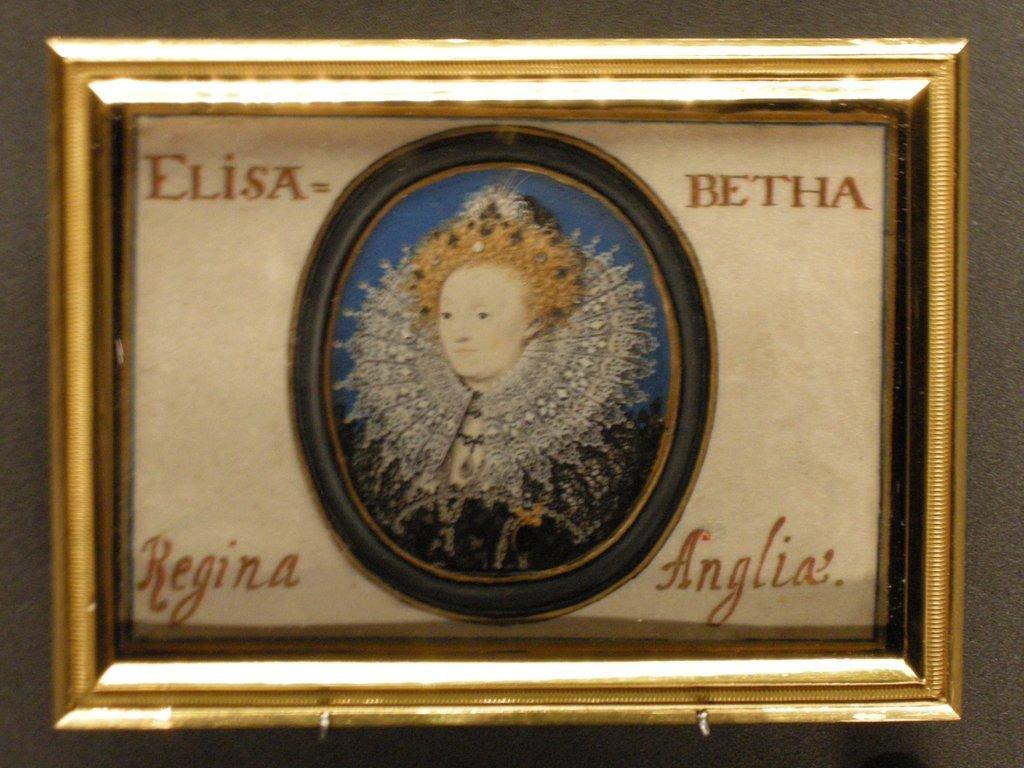<image>
Create a compact narrative representing the image presented. A gold frame with a woman pictured in the center and the words Elisa Betha Regina Anglia written around the photo. 